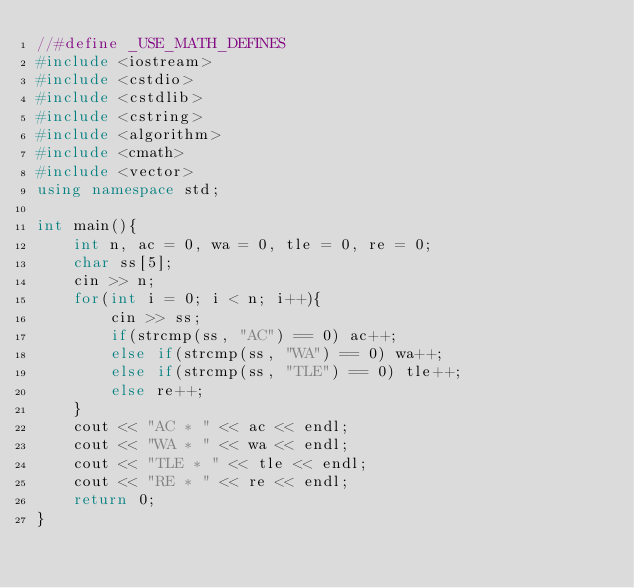Convert code to text. <code><loc_0><loc_0><loc_500><loc_500><_C++_>//#define _USE_MATH_DEFINES
#include <iostream>
#include <cstdio>
#include <cstdlib>
#include <cstring>
#include <algorithm>
#include <cmath>
#include <vector>
using namespace std;

int main(){
	int n, ac = 0, wa = 0, tle = 0, re = 0;
	char ss[5];
	cin >> n;
	for(int i = 0; i < n; i++){
		cin >> ss;
		if(strcmp(ss, "AC") == 0) ac++;
		else if(strcmp(ss, "WA") == 0) wa++;
		else if(strcmp(ss, "TLE") == 0) tle++;
		else re++;
	}
	cout << "AC * " << ac << endl;
	cout << "WA * " << wa << endl;
	cout << "TLE * " << tle << endl;
	cout << "RE * " << re << endl;
	return 0;
}</code> 